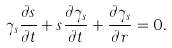Convert formula to latex. <formula><loc_0><loc_0><loc_500><loc_500>\gamma _ { s } \frac { \partial { s } } { \partial { t } } + s \frac { \partial { \gamma _ { s } } } { \partial { t } } + \frac { \partial \gamma _ { s } } { \partial r } = 0 .</formula> 